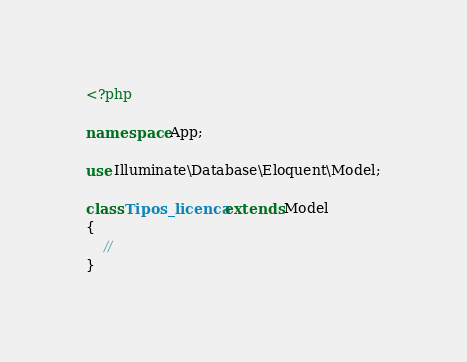Convert code to text. <code><loc_0><loc_0><loc_500><loc_500><_PHP_><?php

namespace App;

use Illuminate\Database\Eloquent\Model;

class Tipos_licenca extends Model
{
    //
}
</code> 